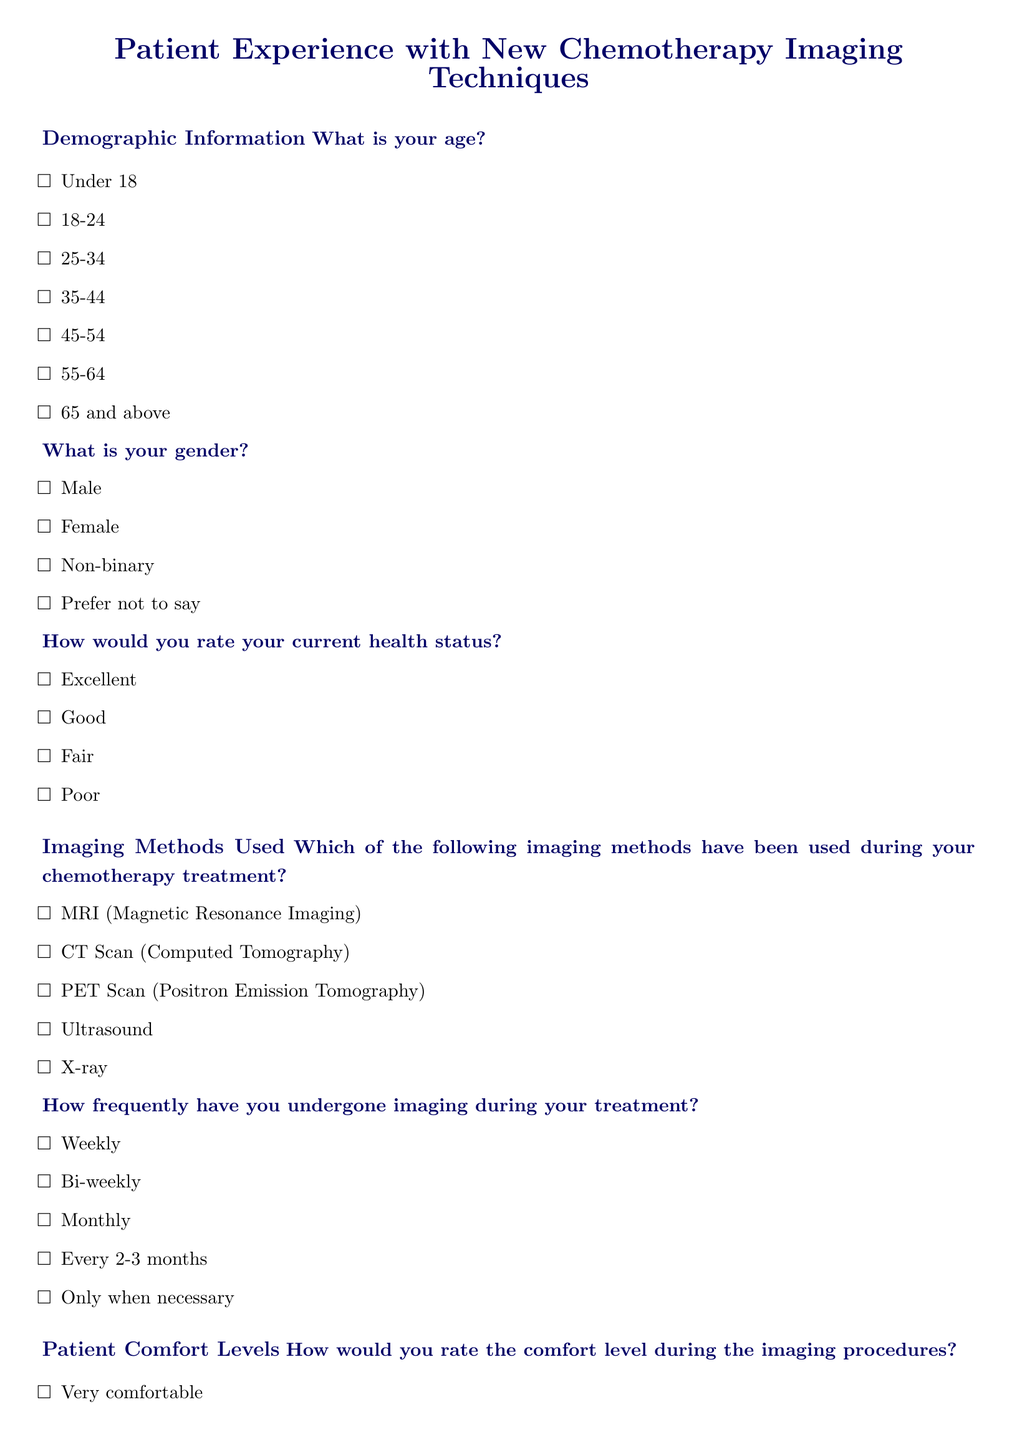What is the age range of survey respondents? The document outlines age categories for respondents, which includes options from "Under 18" to "65 and above."
Answer: Under 18 to 65 and above What imaging method is listed first in the survey? The document lists various imaging methods, starting with "MRI (Magnetic Resonance Imaging)."
Answer: MRI (Magnetic Resonance Imaging) How often can patients undergo imaging according to the survey options? The frequency of imaging during treatment is provided as options, including "Weekly," "Bi-weekly," and others.
Answer: Weekly What is the highest discomfort rating available for imaging agents used? The document offers a scale of discomfort ratings for imaging agents, with "Severe discomfort" as the most extreme option.
Answer: Severe discomfort How do patients rate their overall satisfaction with the imaging techniques? The document contains a satisfaction question that asks for ratings from "Very satisfied" to "Very dissatisfied."
Answer: Very satisfied to Very dissatisfied How frequently do patients report that imaging results influence treatment plans? The document outlines options that range from "Always" to "Never" regarding the influence of imaging on treatment plans.
Answer: Always What optional feedback do patients provide in the survey? The survey includes a final open-ended question for additional comments or suggestions regarding imaging techniques.
Answer: Additional comments or suggestions What minimum health status rating can respondents choose? The survey includes a health status question where respondents can select a minimum rating of "Poor."
Answer: Poor 